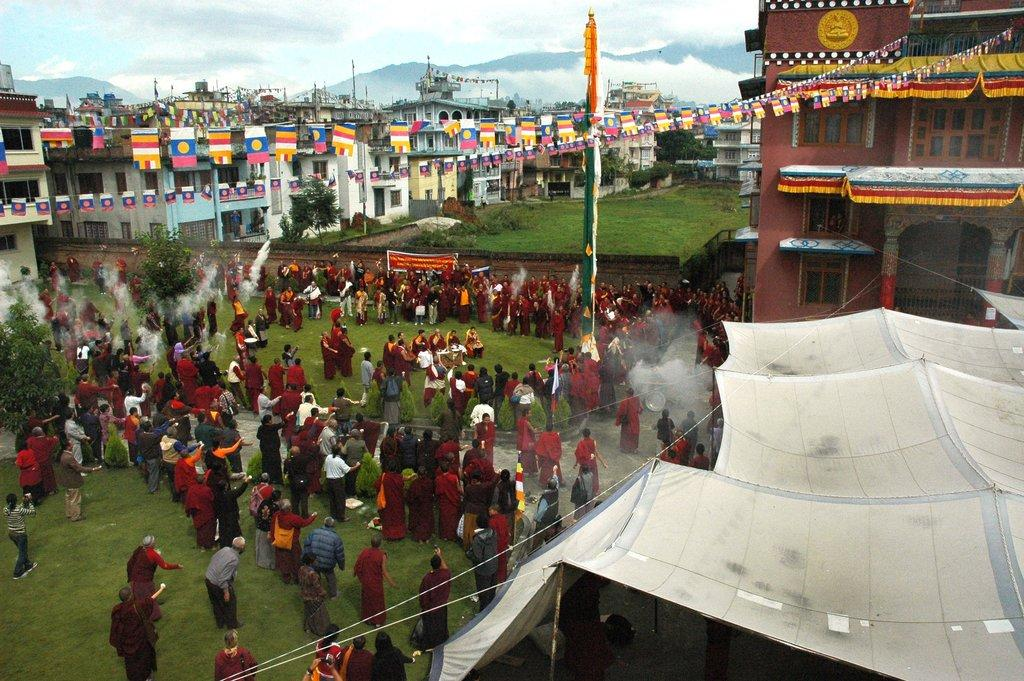How many people are present in the image? There are many people in the image. What can be seen in the image besides people? Flags, tents, buildings, smoke, grass, plants, trees, and hills can be seen in the image. What type of structures are present in the image? Tents and buildings are present in the image. What is the natural environment like in the image? The natural environment includes grass, plants, trees, and hills. What type of goose can be seen taking a bath in the image? There is no goose or bath present in the image. Who is the partner of the person standing next to the tent in the image? The provided facts do not mention any partners or relationships between the people in the image. 